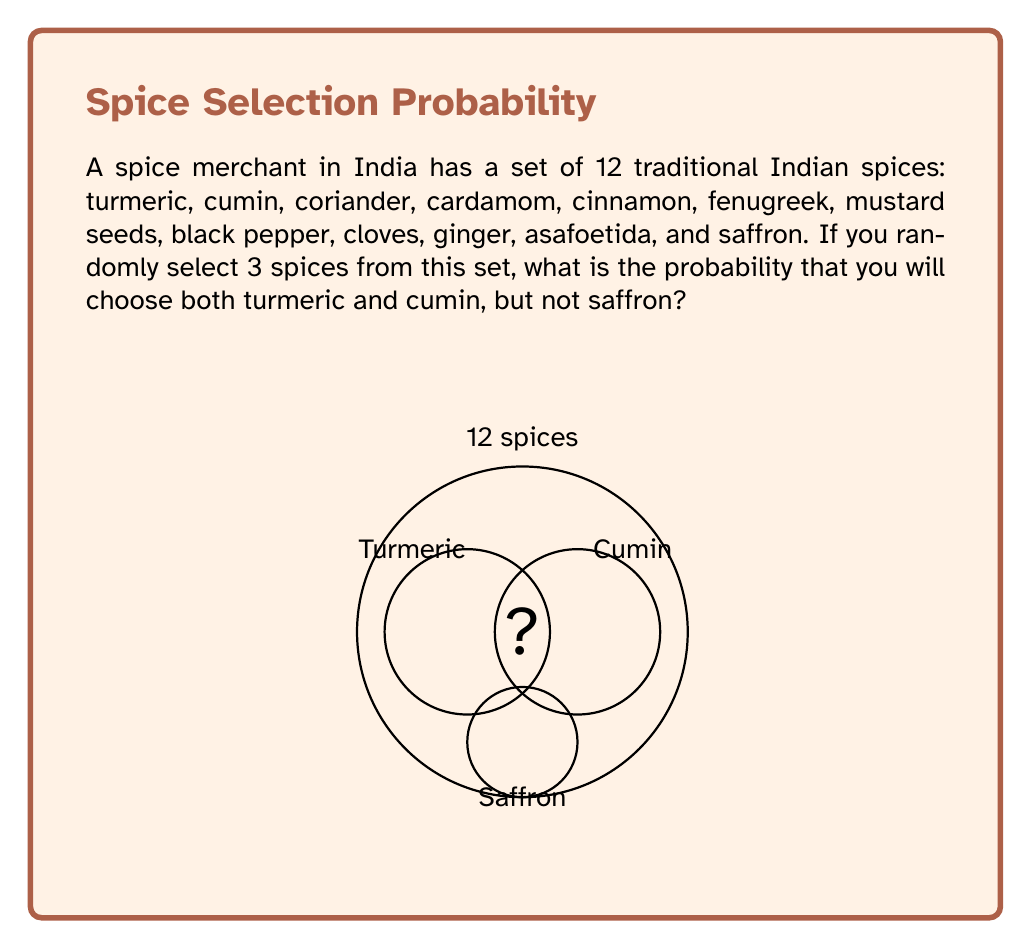Solve this math problem. Let's approach this step-by-step:

1) First, we need to calculate the total number of ways to select 3 spices from 12. This is given by the combination formula:

   $$\binom{12}{3} = \frac{12!}{3!(12-3)!} = \frac{12!}{3!9!} = 220$$

2) Now, we need to select turmeric and cumin (2 spices) and one more spice that is not saffron. 

3) After selecting turmeric and cumin, we have 10 spices left (12 - 2), but we can't select saffron. So we have 9 spices to choose from for our third selection.

4) The number of ways to select 1 spice from 9 is:

   $$\binom{9}{1} = 9$$

5) Therefore, the number of favorable outcomes is 9.

6) The probability is the number of favorable outcomes divided by the total number of possible outcomes:

   $$P(\text{turmeric and cumin, not saffron}) = \frac{9}{220} = \frac{9}{220} = \frac{1}{24} \approx 0.0417$$
Answer: $\frac{1}{24}$ 